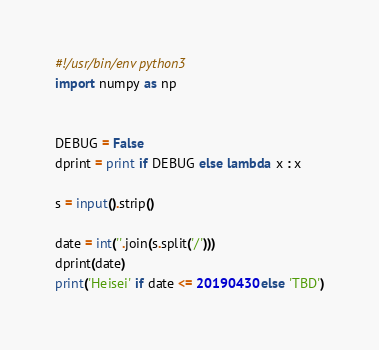<code> <loc_0><loc_0><loc_500><loc_500><_Python_>#!/usr/bin/env python3
import numpy as np


DEBUG = False
dprint = print if DEBUG else lambda x : x

s = input().strip()

date = int(''.join(s.split('/')))
dprint(date)
print('Heisei' if date <= 20190430 else 'TBD')</code> 